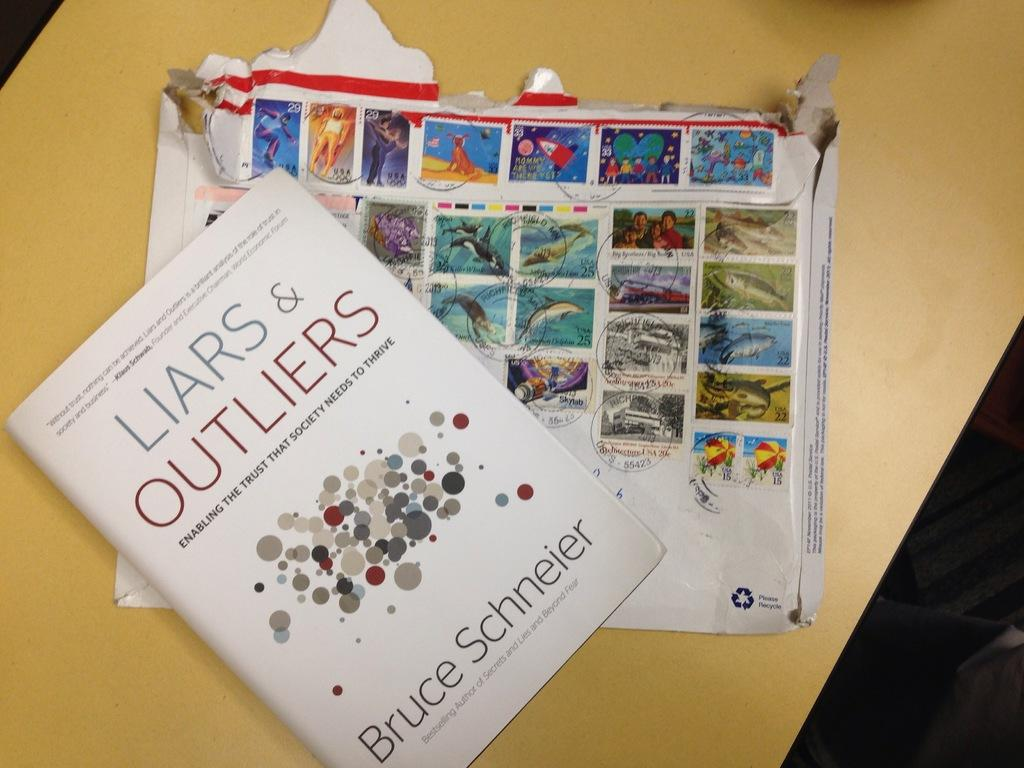<image>
Relay a brief, clear account of the picture shown. A book title LIARS & OUTLIERS by Bruce Schneier sits on a table. 